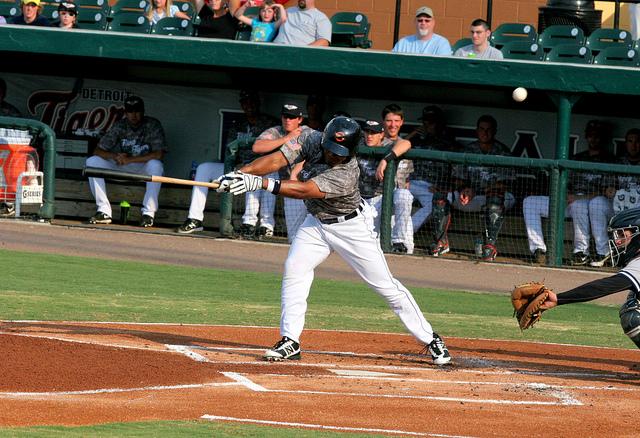How many players are sitting on the bench?
Quick response, please. 8. What team does this player likely play for?
Quick response, please. Tigers. What color is the catcher's mitt?
Be succinct. Brown. How fast is the batter's heart beating?
Write a very short answer. Fast. Who is behind the catcher?
Give a very brief answer. Umpire. Is the batter batting right or left handed?
Short answer required. Left. Did the batter just get a hit?
Quick response, please. Yes. Has the ball been hit?
Short answer required. No. Is the batter wearing a shin guard?
Quick response, please. No. What sport is being played in this picture?
Short answer required. Baseball. 